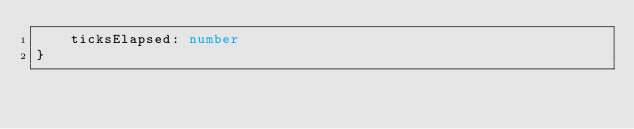Convert code to text. <code><loc_0><loc_0><loc_500><loc_500><_TypeScript_>    ticksElapsed: number
}
</code> 